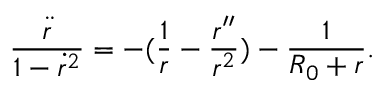<formula> <loc_0><loc_0><loc_500><loc_500>\frac { \ddot { r } } { 1 - \dot { r } ^ { 2 } } = - ( \frac { 1 } { r } - \frac { r ^ { \prime \prime } } { r ^ { 2 } } ) - \frac { 1 } { R _ { 0 } + r } .</formula> 